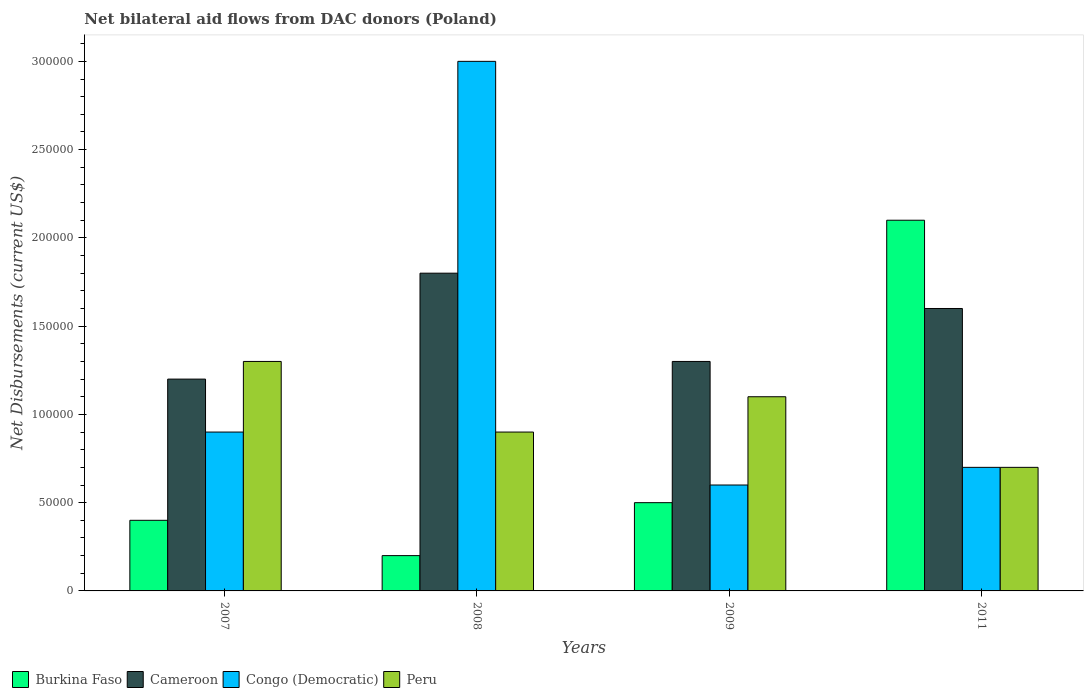How many different coloured bars are there?
Offer a very short reply. 4. How many bars are there on the 2nd tick from the left?
Keep it short and to the point. 4. How many bars are there on the 3rd tick from the right?
Provide a short and direct response. 4. What is the label of the 2nd group of bars from the left?
Your answer should be very brief. 2008. In how many cases, is the number of bars for a given year not equal to the number of legend labels?
Provide a succinct answer. 0. What is the net bilateral aid flows in Congo (Democratic) in 2011?
Offer a terse response. 7.00e+04. Across all years, what is the maximum net bilateral aid flows in Cameroon?
Give a very brief answer. 1.80e+05. In which year was the net bilateral aid flows in Congo (Democratic) maximum?
Offer a terse response. 2008. What is the difference between the net bilateral aid flows in Cameroon in 2011 and the net bilateral aid flows in Congo (Democratic) in 2008?
Make the answer very short. -1.40e+05. What is the average net bilateral aid flows in Congo (Democratic) per year?
Your response must be concise. 1.30e+05. In the year 2009, what is the difference between the net bilateral aid flows in Congo (Democratic) and net bilateral aid flows in Cameroon?
Give a very brief answer. -7.00e+04. What is the ratio of the net bilateral aid flows in Congo (Democratic) in 2007 to that in 2011?
Your answer should be very brief. 1.29. Is the difference between the net bilateral aid flows in Congo (Democratic) in 2009 and 2011 greater than the difference between the net bilateral aid flows in Cameroon in 2009 and 2011?
Provide a short and direct response. Yes. What is the difference between the highest and the second highest net bilateral aid flows in Burkina Faso?
Offer a very short reply. 1.60e+05. In how many years, is the net bilateral aid flows in Peru greater than the average net bilateral aid flows in Peru taken over all years?
Ensure brevity in your answer.  2. What does the 4th bar from the left in 2011 represents?
Give a very brief answer. Peru. What does the 2nd bar from the right in 2011 represents?
Give a very brief answer. Congo (Democratic). Is it the case that in every year, the sum of the net bilateral aid flows in Cameroon and net bilateral aid flows in Congo (Democratic) is greater than the net bilateral aid flows in Burkina Faso?
Make the answer very short. Yes. How many bars are there?
Your answer should be very brief. 16. What is the difference between two consecutive major ticks on the Y-axis?
Make the answer very short. 5.00e+04. Does the graph contain grids?
Give a very brief answer. No. How many legend labels are there?
Provide a short and direct response. 4. What is the title of the graph?
Your answer should be compact. Net bilateral aid flows from DAC donors (Poland). Does "Nicaragua" appear as one of the legend labels in the graph?
Your answer should be compact. No. What is the label or title of the Y-axis?
Offer a terse response. Net Disbursements (current US$). What is the Net Disbursements (current US$) of Burkina Faso in 2007?
Your response must be concise. 4.00e+04. What is the Net Disbursements (current US$) in Congo (Democratic) in 2007?
Provide a succinct answer. 9.00e+04. What is the Net Disbursements (current US$) in Peru in 2007?
Your response must be concise. 1.30e+05. What is the Net Disbursements (current US$) of Cameroon in 2008?
Provide a succinct answer. 1.80e+05. What is the Net Disbursements (current US$) of Burkina Faso in 2009?
Provide a short and direct response. 5.00e+04. What is the Net Disbursements (current US$) in Cameroon in 2009?
Provide a succinct answer. 1.30e+05. What is the Net Disbursements (current US$) of Congo (Democratic) in 2011?
Provide a short and direct response. 7.00e+04. What is the Net Disbursements (current US$) in Peru in 2011?
Provide a succinct answer. 7.00e+04. Across all years, what is the minimum Net Disbursements (current US$) of Burkina Faso?
Ensure brevity in your answer.  2.00e+04. What is the total Net Disbursements (current US$) in Burkina Faso in the graph?
Make the answer very short. 3.20e+05. What is the total Net Disbursements (current US$) in Cameroon in the graph?
Your answer should be very brief. 5.90e+05. What is the total Net Disbursements (current US$) in Congo (Democratic) in the graph?
Offer a very short reply. 5.20e+05. What is the total Net Disbursements (current US$) of Peru in the graph?
Provide a succinct answer. 4.00e+05. What is the difference between the Net Disbursements (current US$) of Burkina Faso in 2007 and that in 2008?
Keep it short and to the point. 2.00e+04. What is the difference between the Net Disbursements (current US$) in Congo (Democratic) in 2007 and that in 2009?
Your answer should be very brief. 3.00e+04. What is the difference between the Net Disbursements (current US$) in Burkina Faso in 2007 and that in 2011?
Your answer should be compact. -1.70e+05. What is the difference between the Net Disbursements (current US$) of Cameroon in 2007 and that in 2011?
Your answer should be compact. -4.00e+04. What is the difference between the Net Disbursements (current US$) of Congo (Democratic) in 2007 and that in 2011?
Your response must be concise. 2.00e+04. What is the difference between the Net Disbursements (current US$) of Peru in 2007 and that in 2011?
Provide a short and direct response. 6.00e+04. What is the difference between the Net Disbursements (current US$) of Burkina Faso in 2008 and that in 2009?
Make the answer very short. -3.00e+04. What is the difference between the Net Disbursements (current US$) in Congo (Democratic) in 2008 and that in 2011?
Make the answer very short. 2.30e+05. What is the difference between the Net Disbursements (current US$) of Peru in 2008 and that in 2011?
Make the answer very short. 2.00e+04. What is the difference between the Net Disbursements (current US$) of Peru in 2009 and that in 2011?
Provide a succinct answer. 4.00e+04. What is the difference between the Net Disbursements (current US$) in Cameroon in 2007 and the Net Disbursements (current US$) in Congo (Democratic) in 2008?
Your answer should be compact. -1.80e+05. What is the difference between the Net Disbursements (current US$) in Cameroon in 2007 and the Net Disbursements (current US$) in Peru in 2008?
Give a very brief answer. 3.00e+04. What is the difference between the Net Disbursements (current US$) in Burkina Faso in 2007 and the Net Disbursements (current US$) in Congo (Democratic) in 2009?
Give a very brief answer. -2.00e+04. What is the difference between the Net Disbursements (current US$) of Cameroon in 2007 and the Net Disbursements (current US$) of Congo (Democratic) in 2009?
Your answer should be very brief. 6.00e+04. What is the difference between the Net Disbursements (current US$) in Congo (Democratic) in 2007 and the Net Disbursements (current US$) in Peru in 2009?
Make the answer very short. -2.00e+04. What is the difference between the Net Disbursements (current US$) in Burkina Faso in 2007 and the Net Disbursements (current US$) in Congo (Democratic) in 2011?
Provide a succinct answer. -3.00e+04. What is the difference between the Net Disbursements (current US$) of Cameroon in 2007 and the Net Disbursements (current US$) of Peru in 2011?
Your answer should be compact. 5.00e+04. What is the difference between the Net Disbursements (current US$) in Cameroon in 2008 and the Net Disbursements (current US$) in Congo (Democratic) in 2009?
Offer a terse response. 1.20e+05. What is the difference between the Net Disbursements (current US$) of Burkina Faso in 2008 and the Net Disbursements (current US$) of Congo (Democratic) in 2011?
Provide a succinct answer. -5.00e+04. What is the difference between the Net Disbursements (current US$) of Burkina Faso in 2008 and the Net Disbursements (current US$) of Peru in 2011?
Ensure brevity in your answer.  -5.00e+04. What is the difference between the Net Disbursements (current US$) of Cameroon in 2008 and the Net Disbursements (current US$) of Peru in 2011?
Provide a succinct answer. 1.10e+05. What is the difference between the Net Disbursements (current US$) in Congo (Democratic) in 2008 and the Net Disbursements (current US$) in Peru in 2011?
Provide a succinct answer. 2.30e+05. What is the difference between the Net Disbursements (current US$) in Cameroon in 2009 and the Net Disbursements (current US$) in Congo (Democratic) in 2011?
Ensure brevity in your answer.  6.00e+04. What is the difference between the Net Disbursements (current US$) of Congo (Democratic) in 2009 and the Net Disbursements (current US$) of Peru in 2011?
Offer a terse response. -10000. What is the average Net Disbursements (current US$) in Burkina Faso per year?
Ensure brevity in your answer.  8.00e+04. What is the average Net Disbursements (current US$) in Cameroon per year?
Offer a very short reply. 1.48e+05. In the year 2007, what is the difference between the Net Disbursements (current US$) in Burkina Faso and Net Disbursements (current US$) in Cameroon?
Your response must be concise. -8.00e+04. In the year 2007, what is the difference between the Net Disbursements (current US$) in Burkina Faso and Net Disbursements (current US$) in Congo (Democratic)?
Provide a succinct answer. -5.00e+04. In the year 2007, what is the difference between the Net Disbursements (current US$) in Burkina Faso and Net Disbursements (current US$) in Peru?
Give a very brief answer. -9.00e+04. In the year 2007, what is the difference between the Net Disbursements (current US$) of Congo (Democratic) and Net Disbursements (current US$) of Peru?
Ensure brevity in your answer.  -4.00e+04. In the year 2008, what is the difference between the Net Disbursements (current US$) of Burkina Faso and Net Disbursements (current US$) of Congo (Democratic)?
Your answer should be compact. -2.80e+05. In the year 2008, what is the difference between the Net Disbursements (current US$) of Congo (Democratic) and Net Disbursements (current US$) of Peru?
Keep it short and to the point. 2.10e+05. In the year 2009, what is the difference between the Net Disbursements (current US$) of Burkina Faso and Net Disbursements (current US$) of Peru?
Give a very brief answer. -6.00e+04. In the year 2009, what is the difference between the Net Disbursements (current US$) in Cameroon and Net Disbursements (current US$) in Peru?
Keep it short and to the point. 2.00e+04. In the year 2011, what is the difference between the Net Disbursements (current US$) of Burkina Faso and Net Disbursements (current US$) of Cameroon?
Your answer should be very brief. 5.00e+04. What is the ratio of the Net Disbursements (current US$) in Burkina Faso in 2007 to that in 2008?
Your answer should be very brief. 2. What is the ratio of the Net Disbursements (current US$) of Peru in 2007 to that in 2008?
Ensure brevity in your answer.  1.44. What is the ratio of the Net Disbursements (current US$) of Peru in 2007 to that in 2009?
Provide a short and direct response. 1.18. What is the ratio of the Net Disbursements (current US$) of Burkina Faso in 2007 to that in 2011?
Offer a very short reply. 0.19. What is the ratio of the Net Disbursements (current US$) in Congo (Democratic) in 2007 to that in 2011?
Provide a short and direct response. 1.29. What is the ratio of the Net Disbursements (current US$) of Peru in 2007 to that in 2011?
Ensure brevity in your answer.  1.86. What is the ratio of the Net Disbursements (current US$) in Burkina Faso in 2008 to that in 2009?
Offer a terse response. 0.4. What is the ratio of the Net Disbursements (current US$) in Cameroon in 2008 to that in 2009?
Your response must be concise. 1.38. What is the ratio of the Net Disbursements (current US$) of Peru in 2008 to that in 2009?
Keep it short and to the point. 0.82. What is the ratio of the Net Disbursements (current US$) in Burkina Faso in 2008 to that in 2011?
Your answer should be compact. 0.1. What is the ratio of the Net Disbursements (current US$) of Cameroon in 2008 to that in 2011?
Keep it short and to the point. 1.12. What is the ratio of the Net Disbursements (current US$) of Congo (Democratic) in 2008 to that in 2011?
Your response must be concise. 4.29. What is the ratio of the Net Disbursements (current US$) in Peru in 2008 to that in 2011?
Keep it short and to the point. 1.29. What is the ratio of the Net Disbursements (current US$) of Burkina Faso in 2009 to that in 2011?
Give a very brief answer. 0.24. What is the ratio of the Net Disbursements (current US$) of Cameroon in 2009 to that in 2011?
Give a very brief answer. 0.81. What is the ratio of the Net Disbursements (current US$) of Congo (Democratic) in 2009 to that in 2011?
Offer a terse response. 0.86. What is the ratio of the Net Disbursements (current US$) in Peru in 2009 to that in 2011?
Provide a short and direct response. 1.57. What is the difference between the highest and the second highest Net Disbursements (current US$) of Congo (Democratic)?
Your response must be concise. 2.10e+05. What is the difference between the highest and the lowest Net Disbursements (current US$) of Congo (Democratic)?
Offer a very short reply. 2.40e+05. What is the difference between the highest and the lowest Net Disbursements (current US$) of Peru?
Provide a short and direct response. 6.00e+04. 